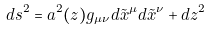<formula> <loc_0><loc_0><loc_500><loc_500>d s ^ { 2 } = a ^ { 2 } ( z ) g _ { \mu \nu } d \tilde { x } ^ { \mu } d \tilde { x } ^ { \nu } + d z ^ { 2 }</formula> 